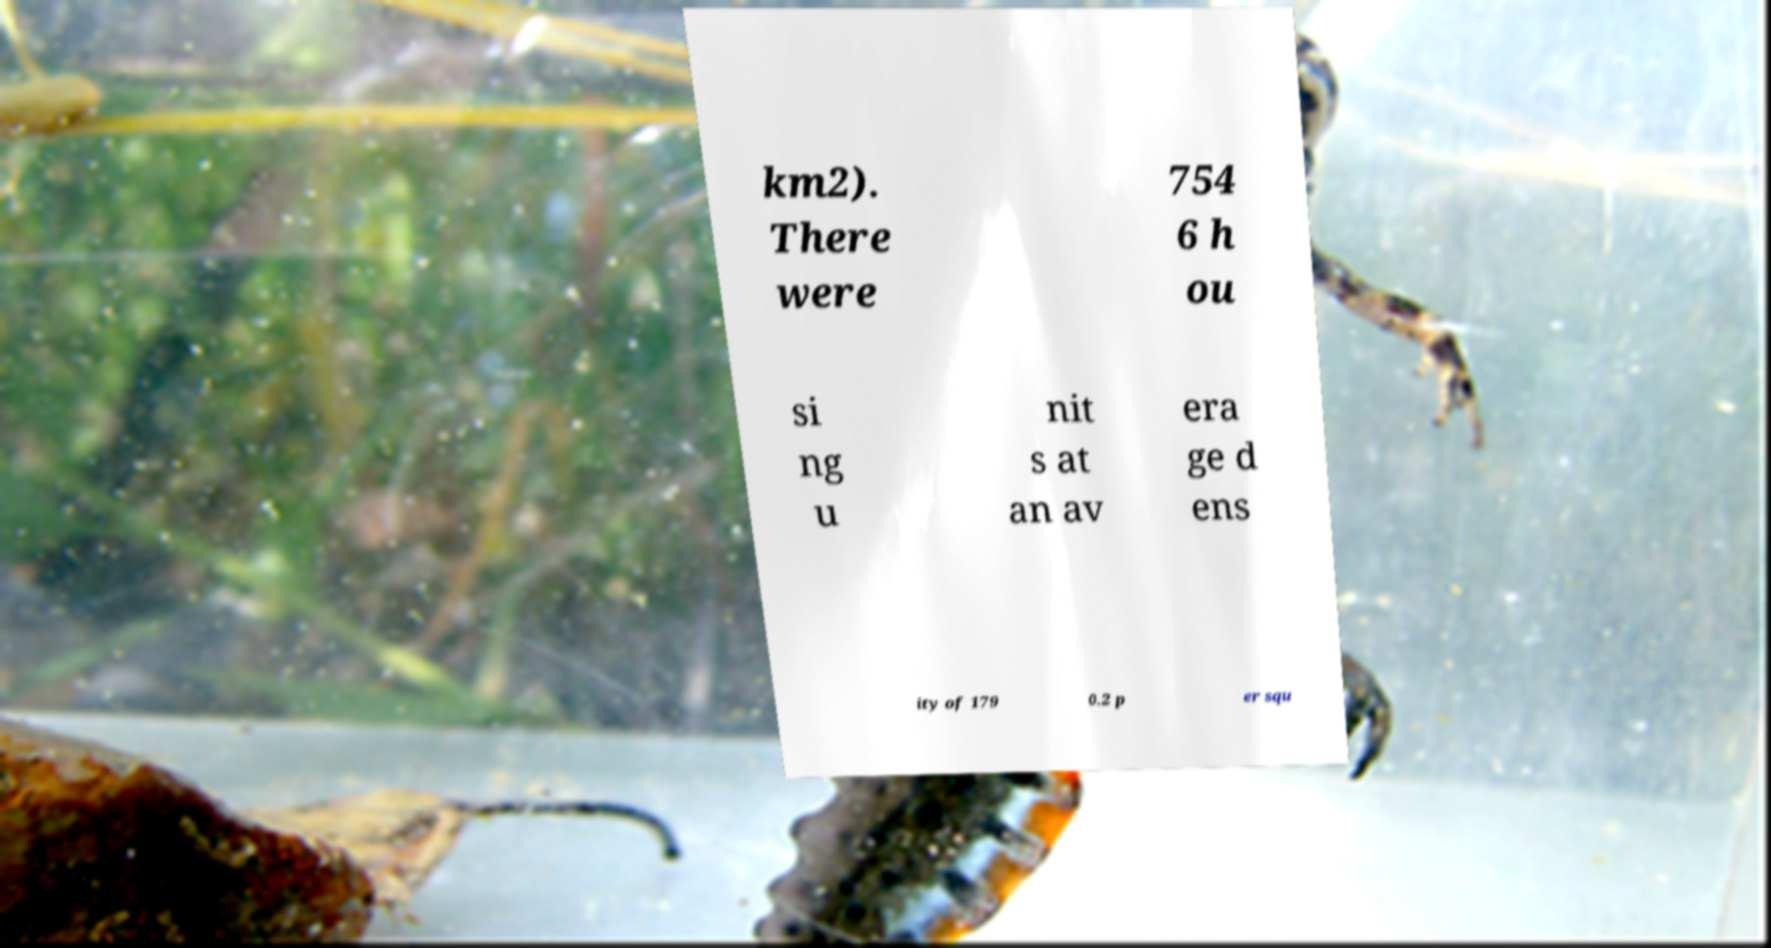Please identify and transcribe the text found in this image. km2). There were 754 6 h ou si ng u nit s at an av era ge d ens ity of 179 0.2 p er squ 